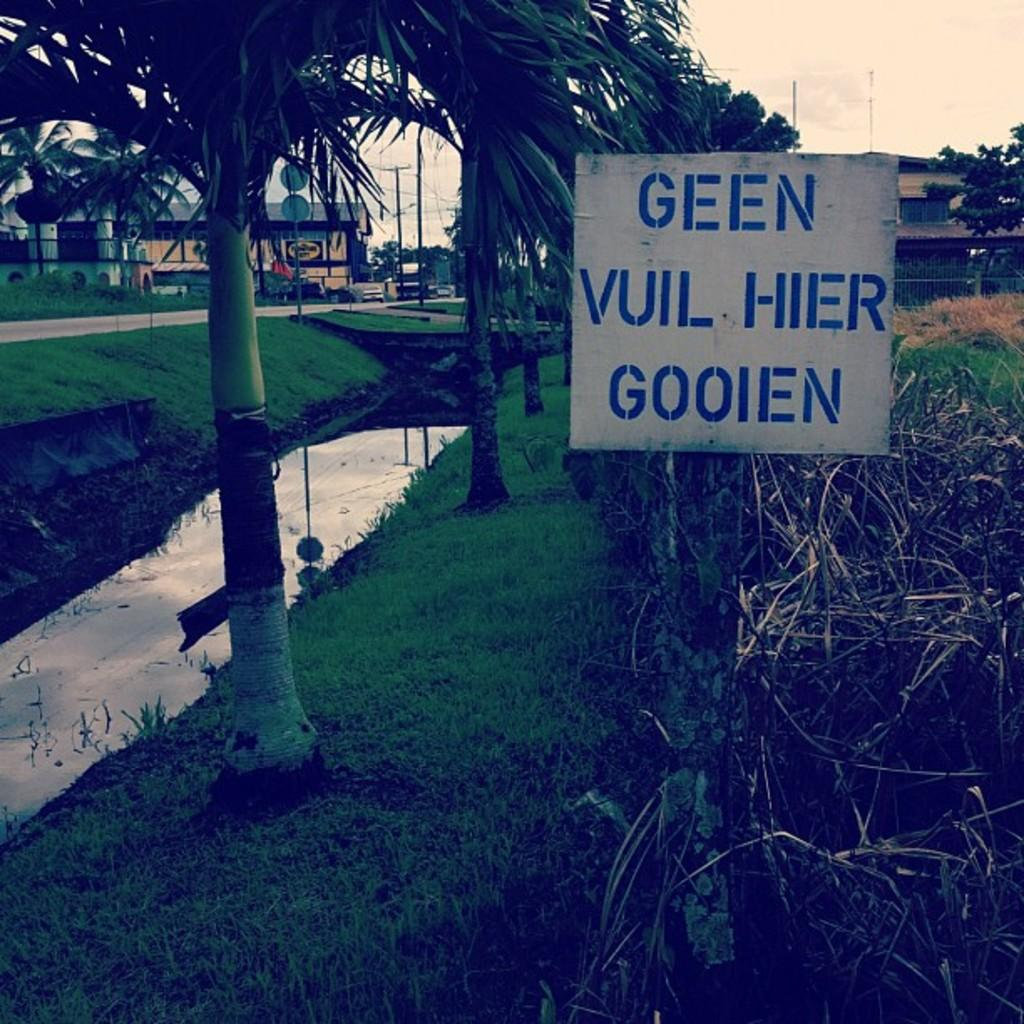What is on the board that is visible in the image? There are words on the board in the image. What type of natural vegetation can be seen in the image? There are trees and grass visible in the image. What type of structures are present in the image? There are buildings and poles visible in the image. How many boards are present in the image? There are multiple boards visible in the image. What is visible in the background of the image? The sky is visible in the background of the image. Is there any water visible in the image? Yes, there is water visible in the image. How many kittens are playing with a locket in the scene depicted in the image? There is no scene with kittens or a locket present in the image. What type of scene is depicted in the image? The image does not depict a scene; it contains a board with words, trees, buildings, poles, boards, grass, water, and a visible sky. 